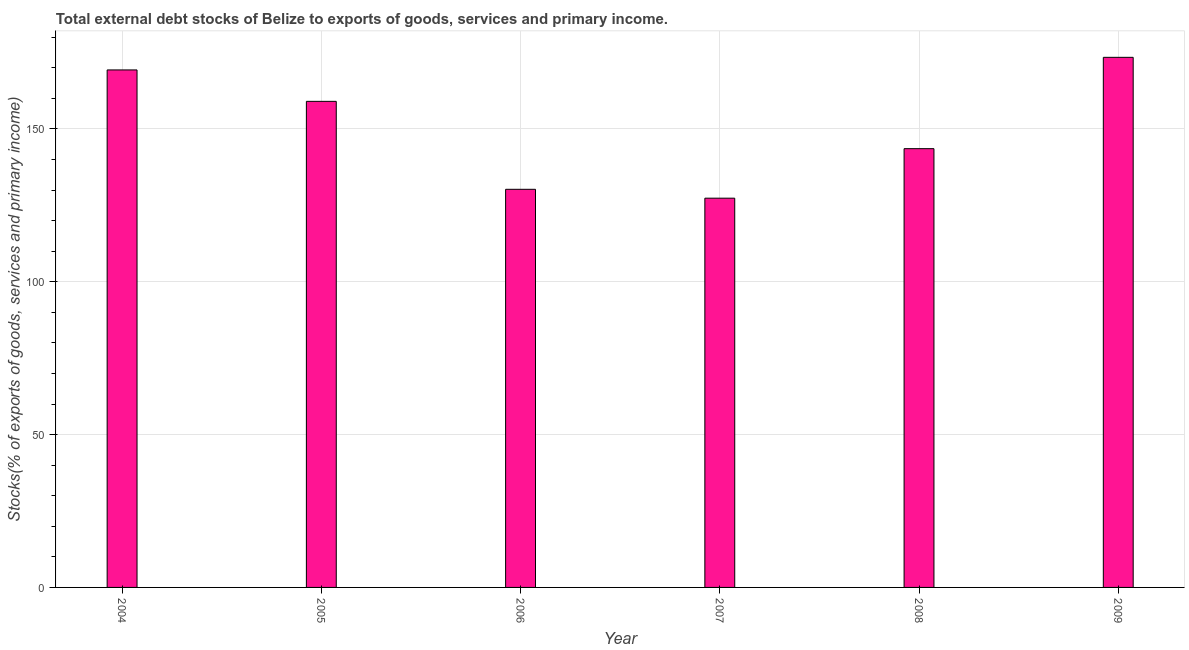Does the graph contain any zero values?
Provide a short and direct response. No. What is the title of the graph?
Provide a short and direct response. Total external debt stocks of Belize to exports of goods, services and primary income. What is the label or title of the X-axis?
Your answer should be very brief. Year. What is the label or title of the Y-axis?
Your answer should be very brief. Stocks(% of exports of goods, services and primary income). What is the external debt stocks in 2007?
Provide a short and direct response. 127.35. Across all years, what is the maximum external debt stocks?
Your answer should be very brief. 173.43. Across all years, what is the minimum external debt stocks?
Your answer should be very brief. 127.35. In which year was the external debt stocks maximum?
Ensure brevity in your answer.  2009. In which year was the external debt stocks minimum?
Your response must be concise. 2007. What is the sum of the external debt stocks?
Your response must be concise. 902.93. What is the difference between the external debt stocks in 2006 and 2007?
Ensure brevity in your answer.  2.9. What is the average external debt stocks per year?
Your answer should be very brief. 150.49. What is the median external debt stocks?
Keep it short and to the point. 151.29. In how many years, is the external debt stocks greater than 30 %?
Offer a very short reply. 6. What is the ratio of the external debt stocks in 2004 to that in 2007?
Give a very brief answer. 1.33. What is the difference between the highest and the second highest external debt stocks?
Ensure brevity in your answer.  4.12. What is the difference between the highest and the lowest external debt stocks?
Your answer should be very brief. 46.08. In how many years, is the external debt stocks greater than the average external debt stocks taken over all years?
Your answer should be compact. 3. How many bars are there?
Give a very brief answer. 6. How many years are there in the graph?
Your response must be concise. 6. What is the difference between two consecutive major ticks on the Y-axis?
Your answer should be compact. 50. Are the values on the major ticks of Y-axis written in scientific E-notation?
Your answer should be very brief. No. What is the Stocks(% of exports of goods, services and primary income) in 2004?
Provide a succinct answer. 169.31. What is the Stocks(% of exports of goods, services and primary income) of 2005?
Offer a terse response. 159.03. What is the Stocks(% of exports of goods, services and primary income) of 2006?
Offer a terse response. 130.25. What is the Stocks(% of exports of goods, services and primary income) of 2007?
Your answer should be compact. 127.35. What is the Stocks(% of exports of goods, services and primary income) in 2008?
Your answer should be very brief. 143.55. What is the Stocks(% of exports of goods, services and primary income) of 2009?
Provide a succinct answer. 173.43. What is the difference between the Stocks(% of exports of goods, services and primary income) in 2004 and 2005?
Offer a terse response. 10.28. What is the difference between the Stocks(% of exports of goods, services and primary income) in 2004 and 2006?
Your response must be concise. 39.06. What is the difference between the Stocks(% of exports of goods, services and primary income) in 2004 and 2007?
Give a very brief answer. 41.96. What is the difference between the Stocks(% of exports of goods, services and primary income) in 2004 and 2008?
Provide a short and direct response. 25.76. What is the difference between the Stocks(% of exports of goods, services and primary income) in 2004 and 2009?
Your answer should be very brief. -4.12. What is the difference between the Stocks(% of exports of goods, services and primary income) in 2005 and 2006?
Offer a very short reply. 28.78. What is the difference between the Stocks(% of exports of goods, services and primary income) in 2005 and 2007?
Your answer should be compact. 31.68. What is the difference between the Stocks(% of exports of goods, services and primary income) in 2005 and 2008?
Give a very brief answer. 15.48. What is the difference between the Stocks(% of exports of goods, services and primary income) in 2005 and 2009?
Make the answer very short. -14.4. What is the difference between the Stocks(% of exports of goods, services and primary income) in 2006 and 2007?
Keep it short and to the point. 2.9. What is the difference between the Stocks(% of exports of goods, services and primary income) in 2006 and 2008?
Offer a terse response. -13.3. What is the difference between the Stocks(% of exports of goods, services and primary income) in 2006 and 2009?
Offer a terse response. -43.18. What is the difference between the Stocks(% of exports of goods, services and primary income) in 2007 and 2008?
Your answer should be very brief. -16.2. What is the difference between the Stocks(% of exports of goods, services and primary income) in 2007 and 2009?
Your answer should be compact. -46.08. What is the difference between the Stocks(% of exports of goods, services and primary income) in 2008 and 2009?
Provide a short and direct response. -29.88. What is the ratio of the Stocks(% of exports of goods, services and primary income) in 2004 to that in 2005?
Make the answer very short. 1.06. What is the ratio of the Stocks(% of exports of goods, services and primary income) in 2004 to that in 2006?
Give a very brief answer. 1.3. What is the ratio of the Stocks(% of exports of goods, services and primary income) in 2004 to that in 2007?
Your response must be concise. 1.33. What is the ratio of the Stocks(% of exports of goods, services and primary income) in 2004 to that in 2008?
Offer a terse response. 1.18. What is the ratio of the Stocks(% of exports of goods, services and primary income) in 2004 to that in 2009?
Make the answer very short. 0.98. What is the ratio of the Stocks(% of exports of goods, services and primary income) in 2005 to that in 2006?
Your answer should be very brief. 1.22. What is the ratio of the Stocks(% of exports of goods, services and primary income) in 2005 to that in 2007?
Ensure brevity in your answer.  1.25. What is the ratio of the Stocks(% of exports of goods, services and primary income) in 2005 to that in 2008?
Offer a terse response. 1.11. What is the ratio of the Stocks(% of exports of goods, services and primary income) in 2005 to that in 2009?
Provide a short and direct response. 0.92. What is the ratio of the Stocks(% of exports of goods, services and primary income) in 2006 to that in 2008?
Keep it short and to the point. 0.91. What is the ratio of the Stocks(% of exports of goods, services and primary income) in 2006 to that in 2009?
Offer a very short reply. 0.75. What is the ratio of the Stocks(% of exports of goods, services and primary income) in 2007 to that in 2008?
Give a very brief answer. 0.89. What is the ratio of the Stocks(% of exports of goods, services and primary income) in 2007 to that in 2009?
Offer a very short reply. 0.73. What is the ratio of the Stocks(% of exports of goods, services and primary income) in 2008 to that in 2009?
Your answer should be compact. 0.83. 